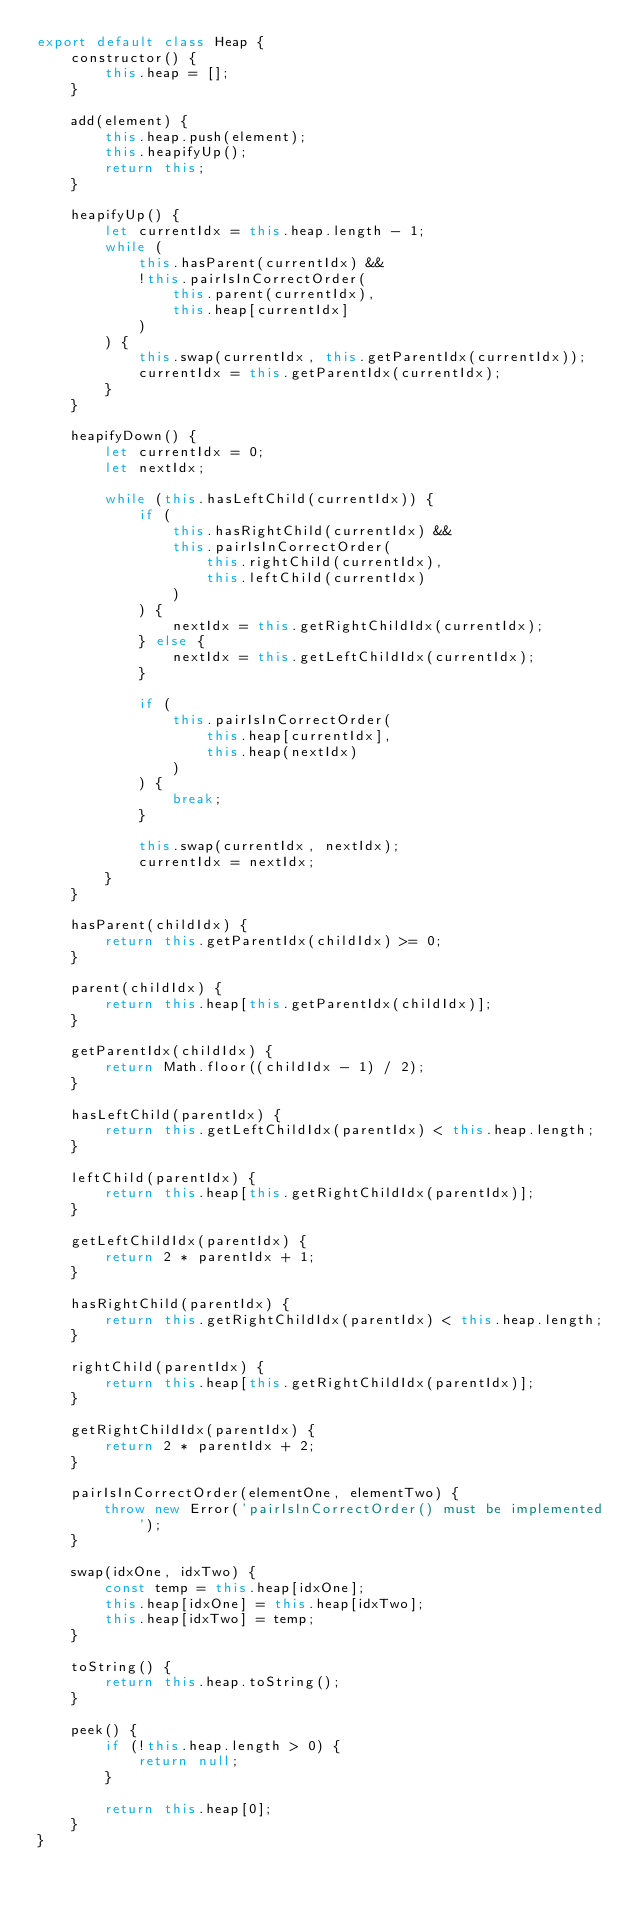<code> <loc_0><loc_0><loc_500><loc_500><_JavaScript_>export default class Heap {
    constructor() {
        this.heap = [];
    }

    add(element) {
        this.heap.push(element);
        this.heapifyUp();
        return this;
    }

    heapifyUp() {
        let currentIdx = this.heap.length - 1;
        while (
            this.hasParent(currentIdx) &&
            !this.pairIsInCorrectOrder(
                this.parent(currentIdx),
                this.heap[currentIdx]
            )
        ) {
            this.swap(currentIdx, this.getParentIdx(currentIdx));
            currentIdx = this.getParentIdx(currentIdx);
        }
    }

    heapifyDown() {
        let currentIdx = 0;
        let nextIdx;

        while (this.hasLeftChild(currentIdx)) {
            if (
                this.hasRightChild(currentIdx) &&
                this.pairIsInCorrectOrder(
                    this.rightChild(currentIdx),
                    this.leftChild(currentIdx)
                )
            ) {
                nextIdx = this.getRightChildIdx(currentIdx);
            } else {
                nextIdx = this.getLeftChildIdx(currentIdx);
            }

            if (
                this.pairIsInCorrectOrder(
                    this.heap[currentIdx],
                    this.heap(nextIdx)
                )
            ) {
                break;
            }

            this.swap(currentIdx, nextIdx);
            currentIdx = nextIdx;
        }
    }

    hasParent(childIdx) {
        return this.getParentIdx(childIdx) >= 0;
    }

    parent(childIdx) {
        return this.heap[this.getParentIdx(childIdx)];
    }

    getParentIdx(childIdx) {
        return Math.floor((childIdx - 1) / 2);
    }

    hasLeftChild(parentIdx) {
        return this.getLeftChildIdx(parentIdx) < this.heap.length;
    }

    leftChild(parentIdx) {
        return this.heap[this.getRightChildIdx(parentIdx)];
    }

    getLeftChildIdx(parentIdx) {
        return 2 * parentIdx + 1;
    }

    hasRightChild(parentIdx) {
        return this.getRightChildIdx(parentIdx) < this.heap.length;
    }

    rightChild(parentIdx) {
        return this.heap[this.getRightChildIdx(parentIdx)];
    }

    getRightChildIdx(parentIdx) {
        return 2 * parentIdx + 2;
    }

    pairIsInCorrectOrder(elementOne, elementTwo) {
        throw new Error('pairIsInCorrectOrder() must be implemented');
    }

    swap(idxOne, idxTwo) {
        const temp = this.heap[idxOne];
        this.heap[idxOne] = this.heap[idxTwo];
        this.heap[idxTwo] = temp;
    }

    toString() {
        return this.heap.toString();
    }

    peek() {
        if (!this.heap.length > 0) {
            return null;
        }

        return this.heap[0];
    }
}
</code> 